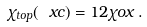Convert formula to latex. <formula><loc_0><loc_0><loc_500><loc_500>\chi _ { t o p } ( \ x c ) = 1 2 \chi o x \, .</formula> 